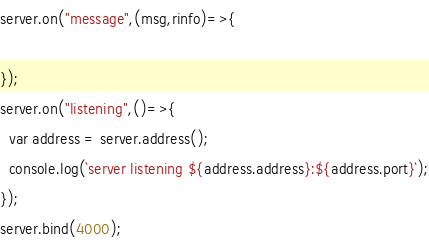Convert code to text. <code><loc_0><loc_0><loc_500><loc_500><_JavaScript_>server.on("message",(msg,rinfo)=>{

});
server.on("listening",()=>{
  var address = server.address();
  console.log(`server listening ${address.address}:${address.port}`);
});
server.bind(4000);
</code> 